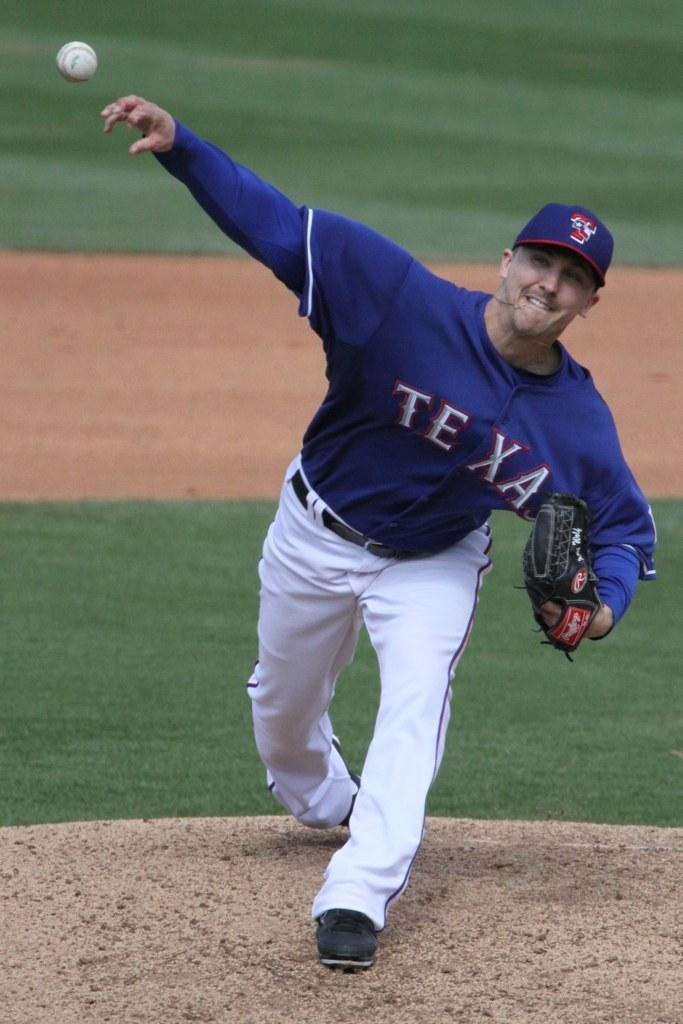<image>
Share a concise interpretation of the image provided. A baseball player with the word Texas on his shirt throws a baseball. 